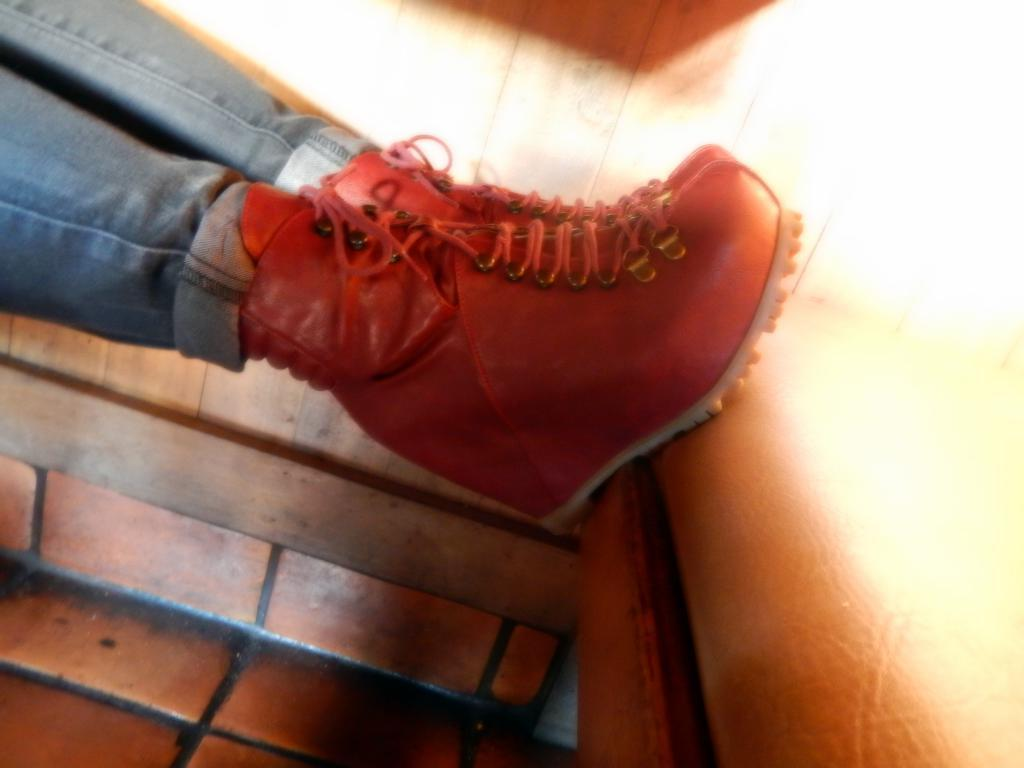What is the main subject of the image? There is a person standing in the image. What part of the person's body can be seen? The person's legs are visible. What type of material is the wall in the background made of? There is a wooden wall in the background of the image. What color is the sock on the person's left foot in the image? There is no sock mentioned or visible in the image. What type of dress is the person wearing in the image? The person's clothing is not specified in the image, so we cannot determine if they are wearing a dress or not. 